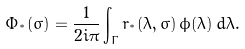Convert formula to latex. <formula><loc_0><loc_0><loc_500><loc_500>\Phi _ { ^ { * } } ( \sigma ) = \frac { 1 } { 2 i \pi } \int _ { \Gamma } r _ { ^ { * } } ( \lambda , \sigma ) \, \phi ( \lambda ) \, d \lambda .</formula> 